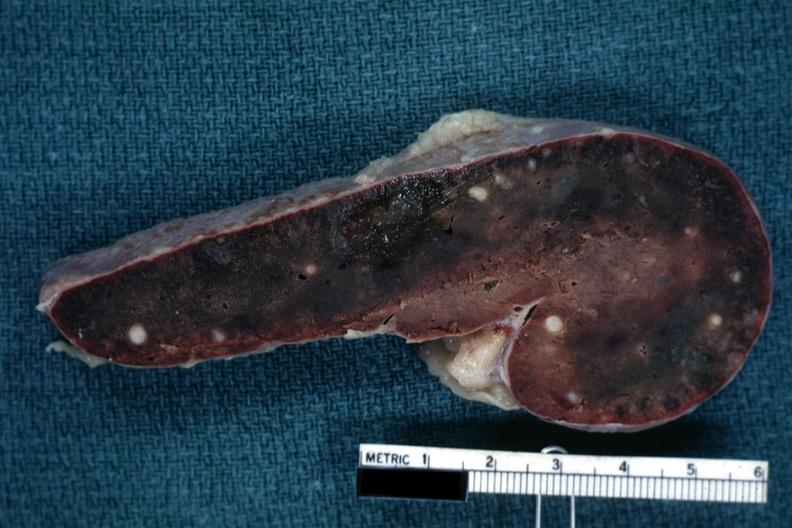what is present?
Answer the question using a single word or phrase. Spleen 